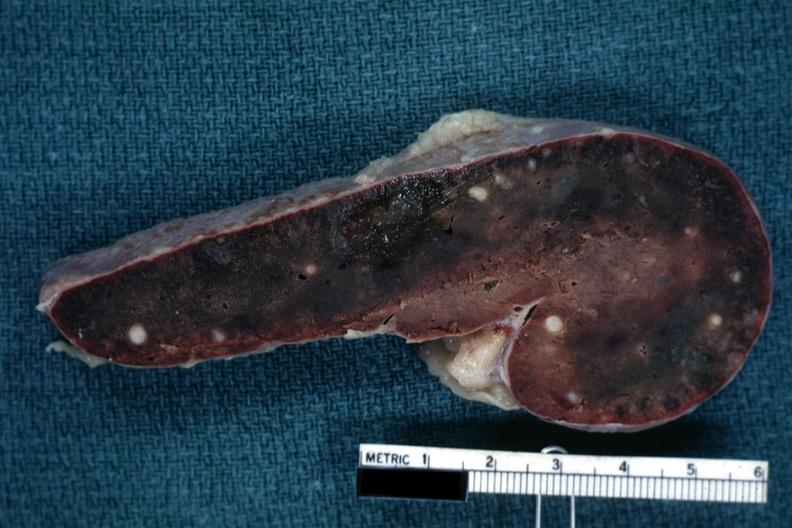what is present?
Answer the question using a single word or phrase. Spleen 